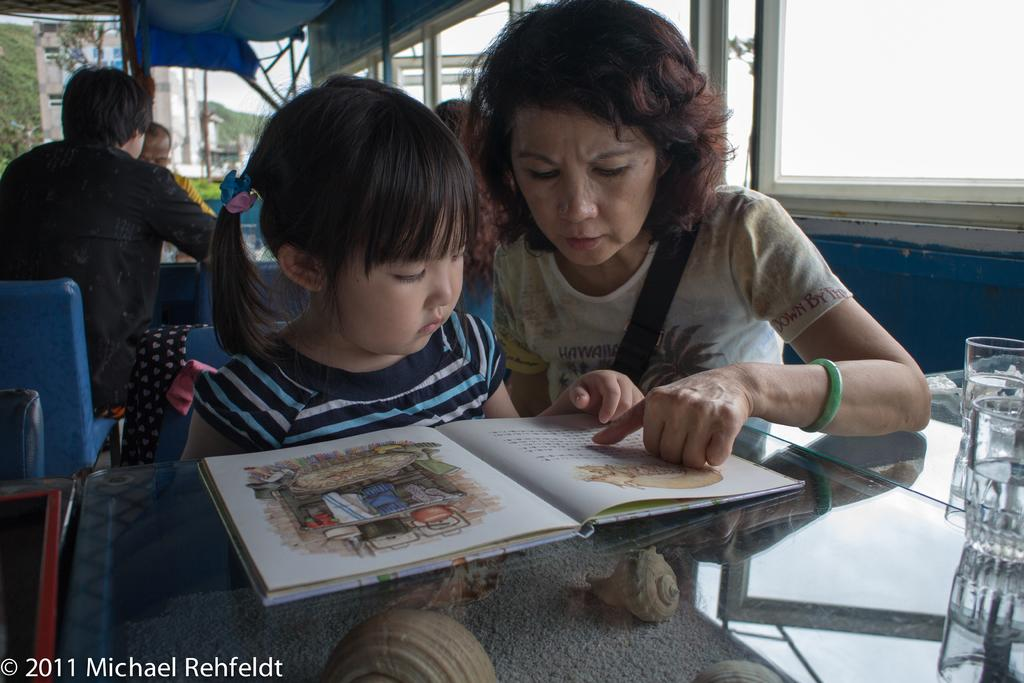Who can be seen in the image? There is a woman and a child in the image. What are they doing in the image? They are sitting on a chair. What is in front of them? There is a table in front of them. What objects are on the table? There is a book and a glass on the table. Are there any other people in the image? Yes, there are people sitting at the back. What can be seen through the window? The facts do not mention anything about the window, so we cannot determine what can be seen through it. How many grapes are on the cover of the book in the image? There are no grapes mentioned in the image, and there is no information about a cover on the book. 